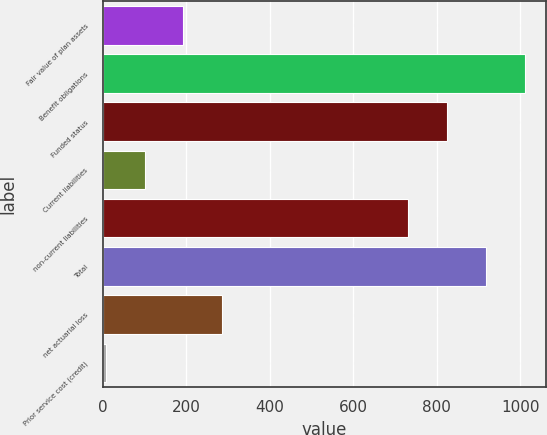Convert chart. <chart><loc_0><loc_0><loc_500><loc_500><bar_chart><fcel>Fair value of plan assets<fcel>Benefit obligations<fcel>Funded status<fcel>Current liabilities<fcel>non-current liabilities<fcel>Total<fcel>net actuarial loss<fcel>Prior service cost (credit)<nl><fcel>193.6<fcel>1011.9<fcel>825.3<fcel>100.3<fcel>732<fcel>918.6<fcel>286.9<fcel>7<nl></chart> 